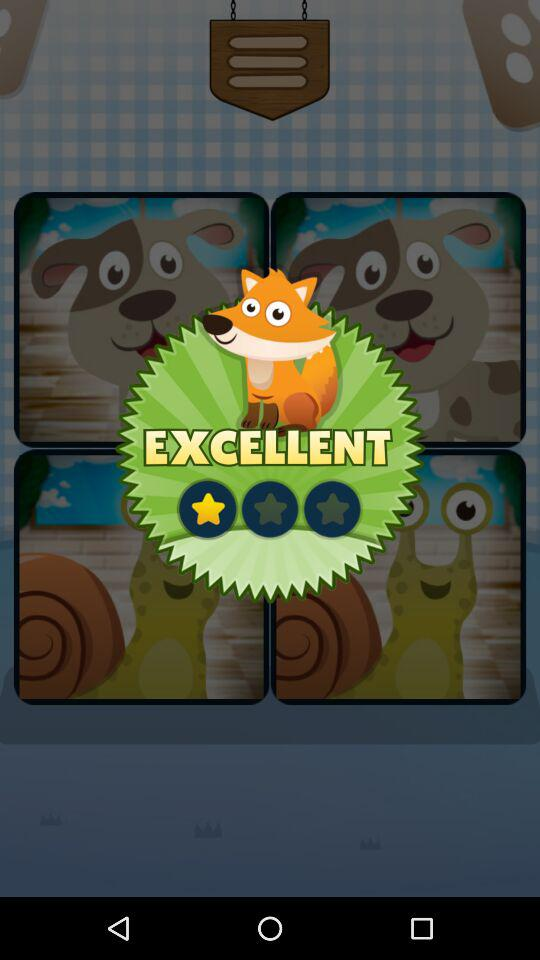What is the rating? The rating is 1 star. 